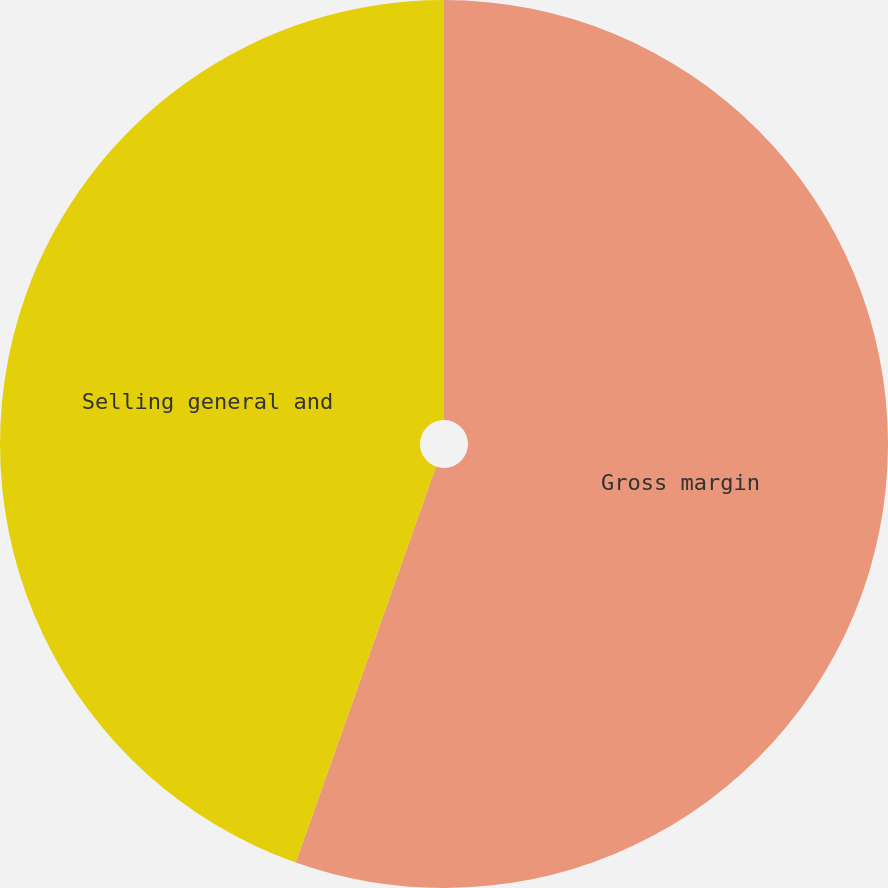Convert chart. <chart><loc_0><loc_0><loc_500><loc_500><pie_chart><fcel>Gross margin<fcel>Selling general and<nl><fcel>55.42%<fcel>44.58%<nl></chart> 